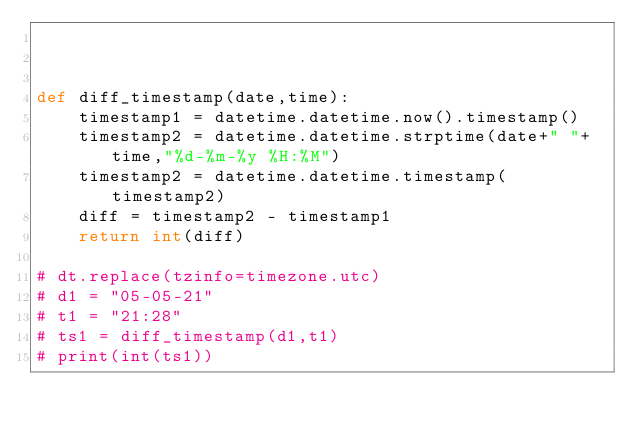Convert code to text. <code><loc_0><loc_0><loc_500><loc_500><_Python_>


def diff_timestamp(date,time):
    timestamp1 = datetime.datetime.now().timestamp()
    timestamp2 = datetime.datetime.strptime(date+" "+time,"%d-%m-%y %H:%M")
    timestamp2 = datetime.datetime.timestamp(timestamp2)
    diff = timestamp2 - timestamp1
    return int(diff)

# dt.replace(tzinfo=timezone.utc)
# d1 = "05-05-21"
# t1 = "21:28"
# ts1 = diff_timestamp(d1,t1)
# print(int(ts1))</code> 